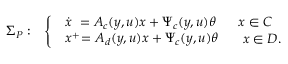<formula> <loc_0><loc_0><loc_500><loc_500>\begin{array} { r l } { \Sigma _ { P } \colon } & { \left \{ \begin{array} { l l } { \begin{array} { l } { \dot { x } \ = A _ { c } ( y , u ) x + \Psi _ { c } ( y , u ) \theta } \end{array} } & { x \in C } \\ { \begin{array} { l } { x ^ { + } \, = A _ { d } ( y , u ) x + \Psi _ { c } ( y , u ) \theta } \end{array} } & { \ x \in D . } \end{array} } \end{array}</formula> 